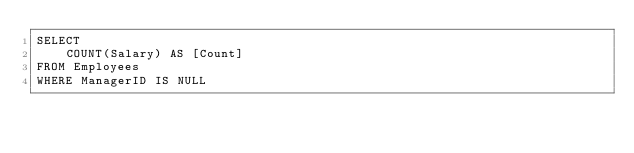<code> <loc_0><loc_0><loc_500><loc_500><_SQL_>SELECT
	COUNT(Salary) AS [Count]
FROM Employees
WHERE ManagerID IS NULL</code> 